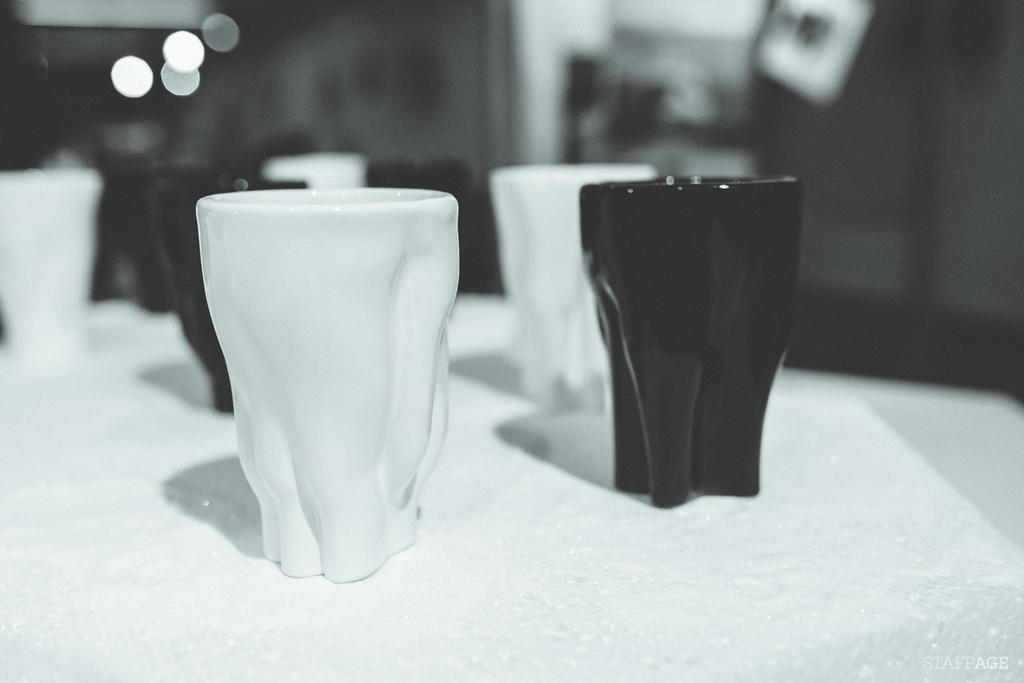What is the color scheme of the image? The image is black and white. What objects are on the table in the image? There are cups on a table in the image. What color are the cups in the image? The cups are in black and white color. What can be seen behind the cups in the image? There is a blue element behind the cups in the image. What is the purpose of the bear in the image? There is no bear present in the image. How does the blue element push the cups in the image? The blue element does not push the cups in the image; it is a stationary background element. 